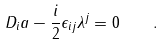<formula> <loc_0><loc_0><loc_500><loc_500>D _ { i } a - { \frac { i } { 2 } } \epsilon _ { i j } \lambda ^ { j } = 0 \quad .</formula> 